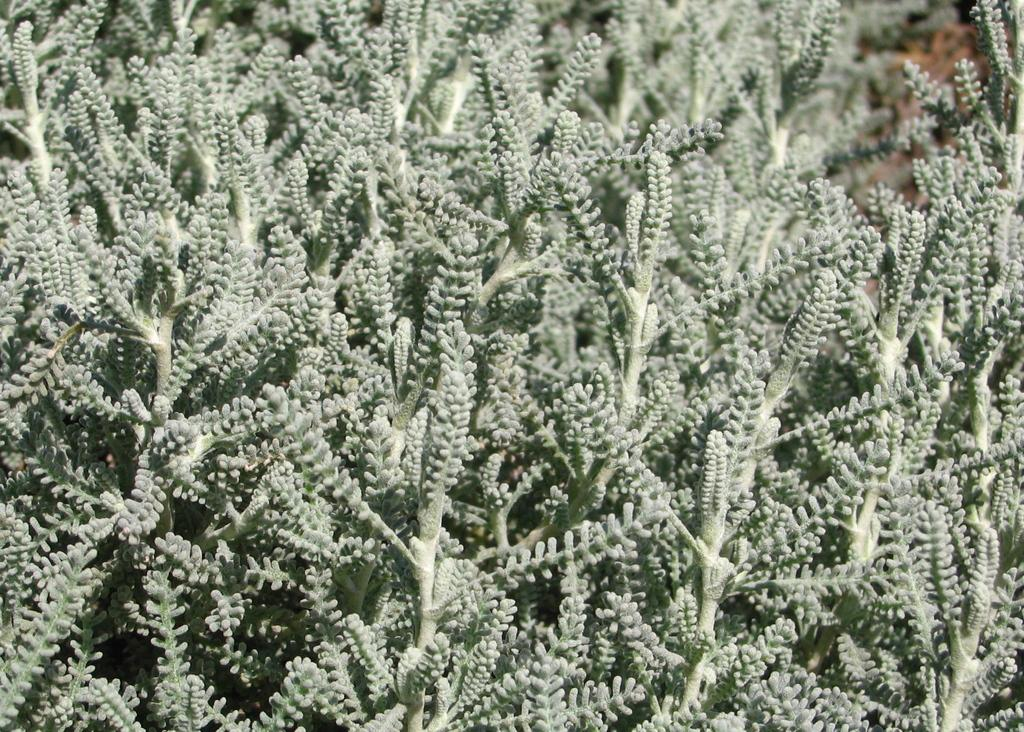What type of living organisms can be seen in the image? Plants can be seen in the image. What type of mouth can be seen on the plants in the image? Plants do not have mouths, so there is no mouth visible on the plants in the image. 